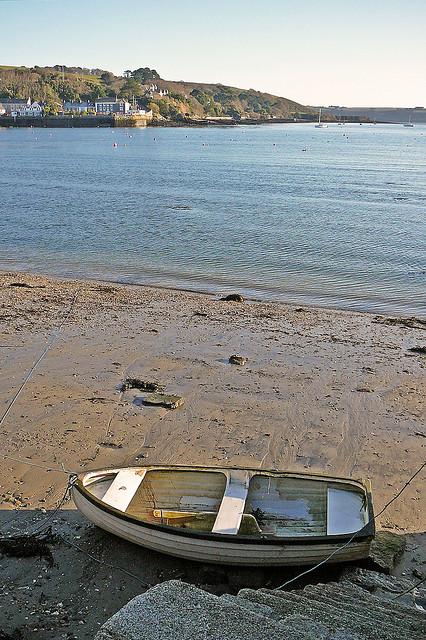What kind of boat is on the sand?
Write a very short answer. Canoe. What is the water?
Give a very brief answer. Lake. Is this a lake or the ocean?
Short answer required. Lake. Are the vessels shown seaworthy?
Be succinct. No. 